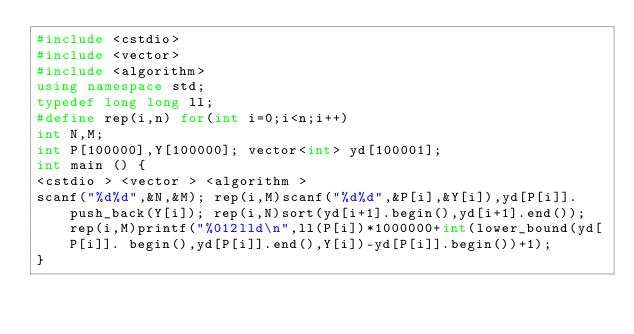<code> <loc_0><loc_0><loc_500><loc_500><_C++_>#include <cstdio>
#include <vector>
#include <algorithm>
using namespace std;
typedef long long ll;
#define rep(i,n) for(int i=0;i<n;i++)
int N,M;
int P[100000],Y[100000]; vector<int> yd[100001];
int main () {
<cstdio > <vector > <algorithm >
scanf("%d%d",&N,&M); rep(i,M)scanf("%d%d",&P[i],&Y[i]),yd[P[i]].push_back(Y[i]); rep(i,N)sort(yd[i+1].begin(),yd[i+1].end()); rep(i,M)printf("%012lld\n",ll(P[i])*1000000+int(lower_bound(yd[P[i]]. begin(),yd[P[i]].end(),Y[i])-yd[P[i]].begin())+1);
}</code> 